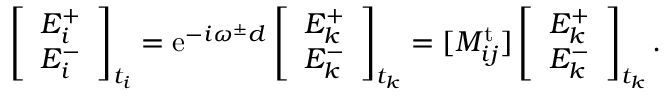<formula> <loc_0><loc_0><loc_500><loc_500>\left [ \begin{array} { l } { E _ { i } ^ { + } } \\ { E _ { i } ^ { - } } \end{array} \right ] _ { t _ { i } } = e ^ { - i \omega ^ { \pm } d } \left [ \begin{array} { l } { E _ { k } ^ { + } } \\ { E _ { k } ^ { - } } \end{array} \right ] _ { t _ { k } } = [ M _ { i j } ^ { t } ] \left [ \begin{array} { l } { E _ { k } ^ { + } } \\ { E _ { k } ^ { - } } \end{array} \right ] _ { t _ { k } } .</formula> 